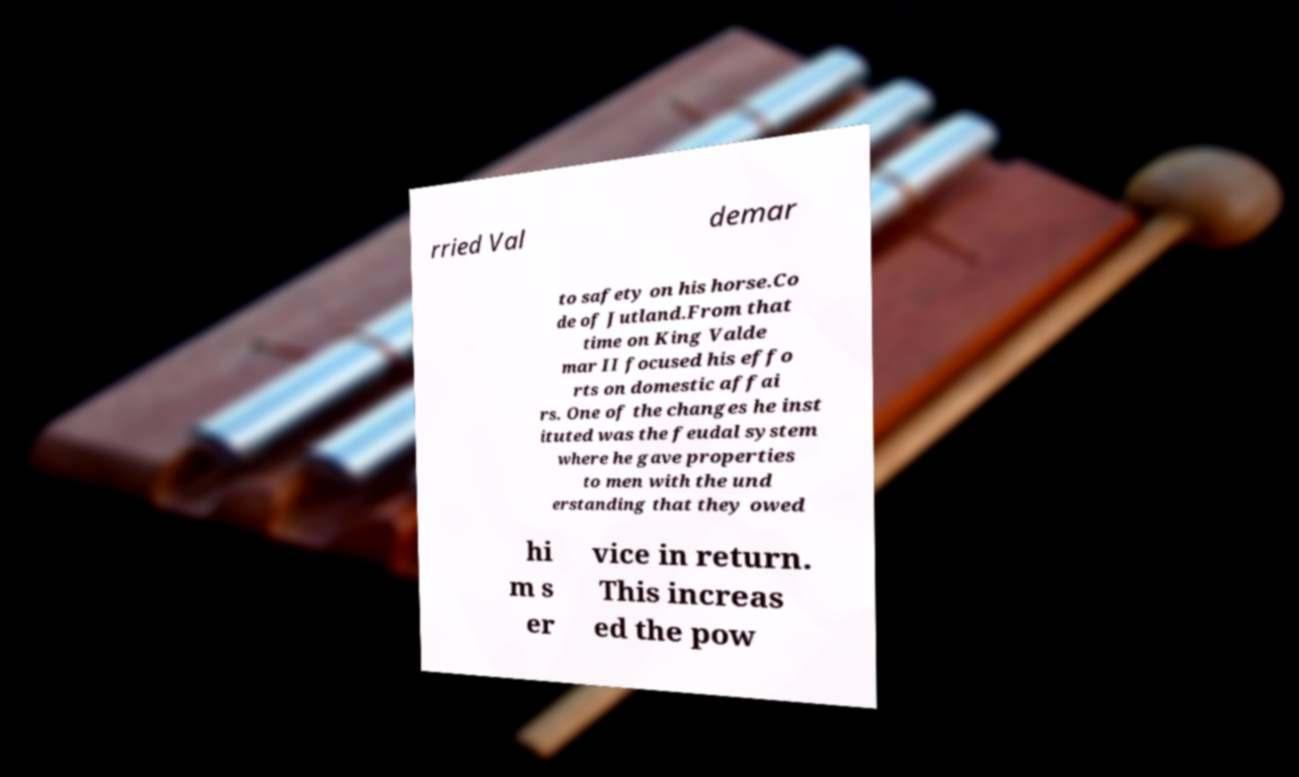There's text embedded in this image that I need extracted. Can you transcribe it verbatim? rried Val demar to safety on his horse.Co de of Jutland.From that time on King Valde mar II focused his effo rts on domestic affai rs. One of the changes he inst ituted was the feudal system where he gave properties to men with the und erstanding that they owed hi m s er vice in return. This increas ed the pow 